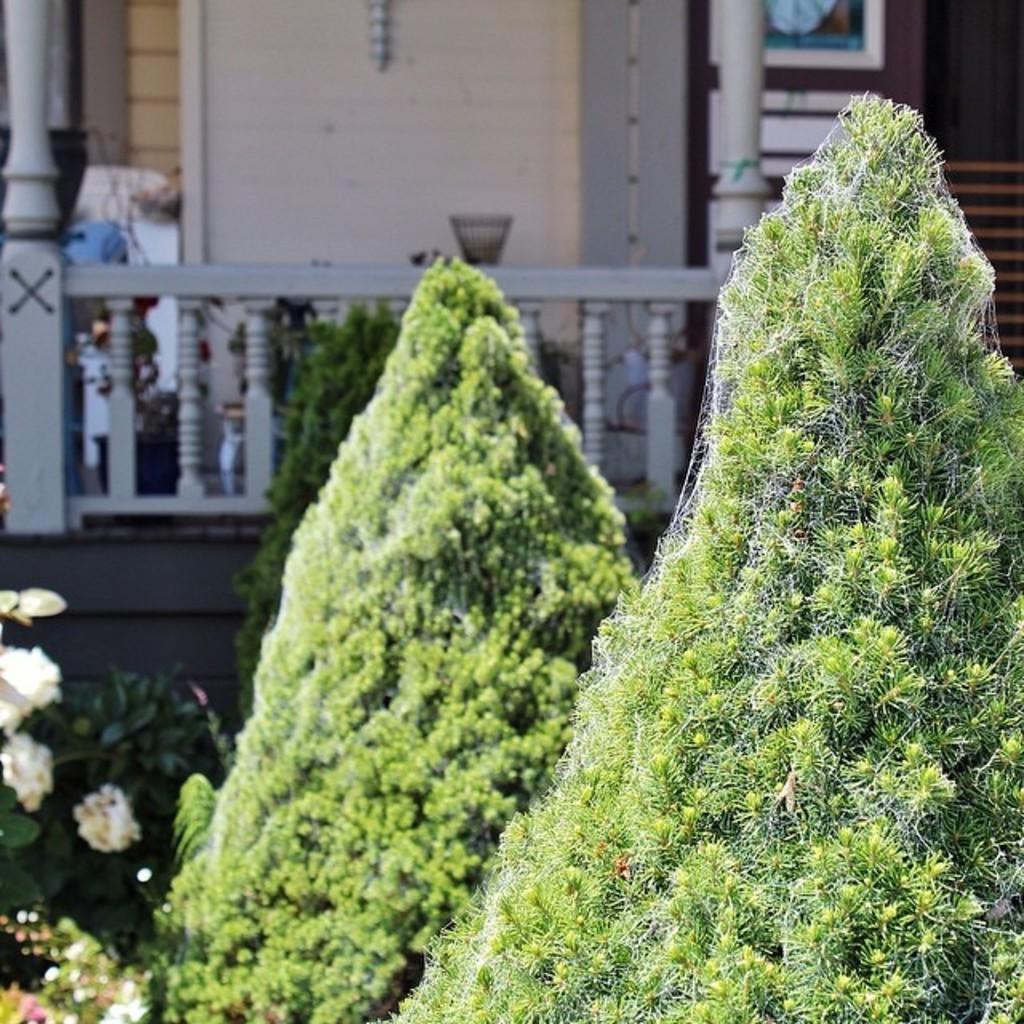How would you summarize this image in a sentence or two? In this image we can see a group of plants with flowers. On the backside we can see a building with poles and a wall. We can also see a bowl which is placed on a fence. 